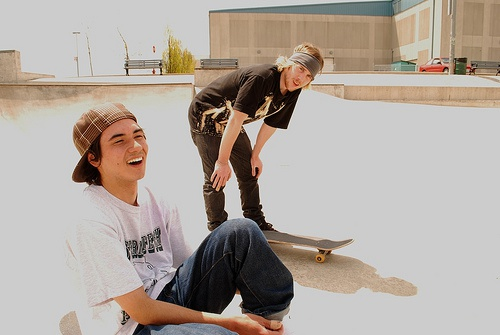Describe the objects in this image and their specific colors. I can see people in lightgray, black, darkgray, and salmon tones, people in lightgray, black, tan, maroon, and gray tones, skateboard in lightgray, gray, tan, and olive tones, bench in lightgray, darkgray, and gray tones, and car in lightgray, salmon, tan, darkgray, and brown tones in this image. 